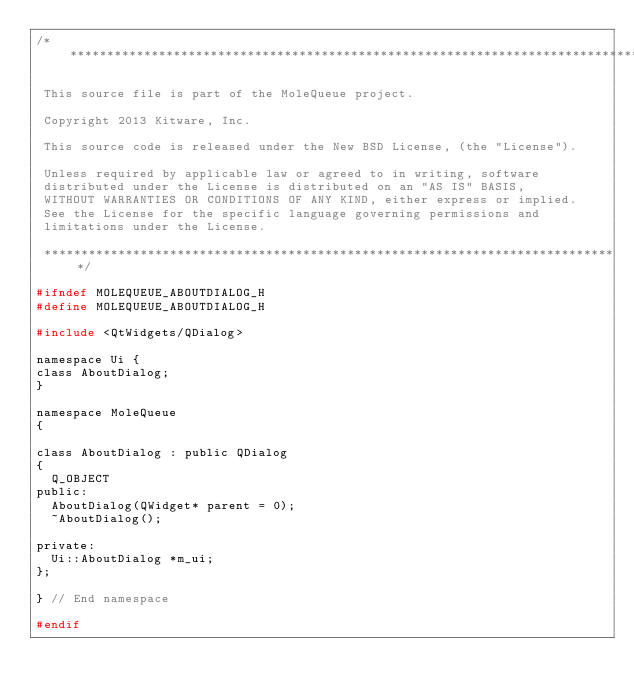Convert code to text. <code><loc_0><loc_0><loc_500><loc_500><_C_>/******************************************************************************

 This source file is part of the MoleQueue project.

 Copyright 2013 Kitware, Inc.

 This source code is released under the New BSD License, (the "License").

 Unless required by applicable law or agreed to in writing, software
 distributed under the License is distributed on an "AS IS" BASIS,
 WITHOUT WARRANTIES OR CONDITIONS OF ANY KIND, either express or implied.
 See the License for the specific language governing permissions and
 limitations under the License.

 ******************************************************************************/

#ifndef MOLEQUEUE_ABOUTDIALOG_H
#define MOLEQUEUE_ABOUTDIALOG_H

#include <QtWidgets/QDialog>

namespace Ui {
class AboutDialog;
}

namespace MoleQueue
{

class AboutDialog : public QDialog
{
  Q_OBJECT
public:
  AboutDialog(QWidget* parent = 0);
  ~AboutDialog();

private:
  Ui::AboutDialog *m_ui;
};

} // End namespace

#endif
</code> 